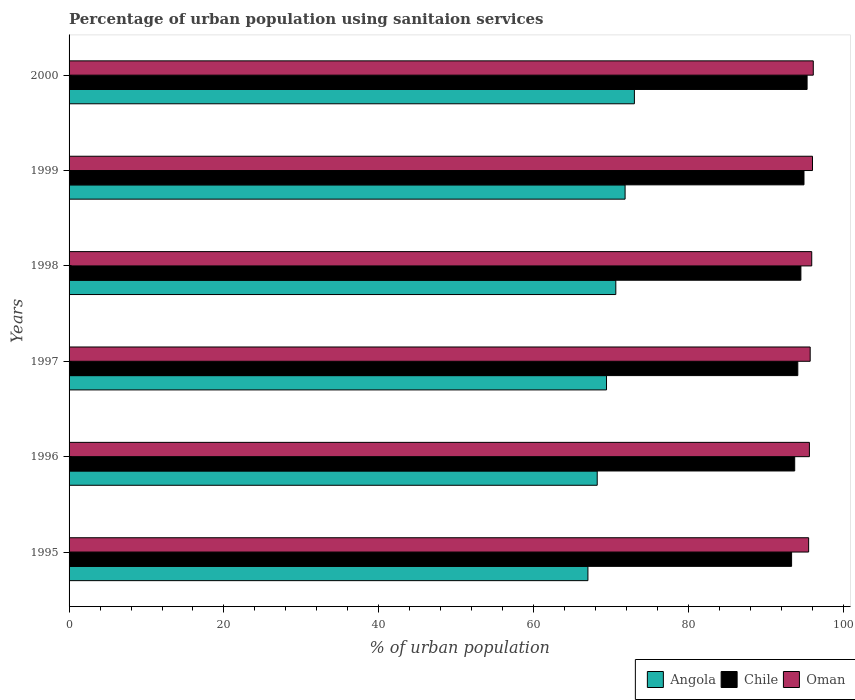How many groups of bars are there?
Offer a very short reply. 6. How many bars are there on the 4th tick from the top?
Offer a terse response. 3. How many bars are there on the 6th tick from the bottom?
Offer a very short reply. 3. In how many cases, is the number of bars for a given year not equal to the number of legend labels?
Ensure brevity in your answer.  0. What is the percentage of urban population using sanitaion services in Angola in 2000?
Ensure brevity in your answer.  73. Across all years, what is the maximum percentage of urban population using sanitaion services in Chile?
Give a very brief answer. 95.3. Across all years, what is the minimum percentage of urban population using sanitaion services in Angola?
Offer a terse response. 67. In which year was the percentage of urban population using sanitaion services in Chile maximum?
Your answer should be compact. 2000. In which year was the percentage of urban population using sanitaion services in Angola minimum?
Offer a very short reply. 1995. What is the total percentage of urban population using sanitaion services in Oman in the graph?
Give a very brief answer. 574.8. What is the difference between the percentage of urban population using sanitaion services in Oman in 1996 and that in 1997?
Your answer should be compact. -0.1. What is the difference between the percentage of urban population using sanitaion services in Angola in 2000 and the percentage of urban population using sanitaion services in Chile in 1997?
Your answer should be compact. -21.1. What is the average percentage of urban population using sanitaion services in Chile per year?
Provide a succinct answer. 94.3. In the year 1996, what is the difference between the percentage of urban population using sanitaion services in Chile and percentage of urban population using sanitaion services in Angola?
Offer a very short reply. 25.5. What is the ratio of the percentage of urban population using sanitaion services in Oman in 1998 to that in 1999?
Your answer should be very brief. 1. Is the difference between the percentage of urban population using sanitaion services in Chile in 1996 and 1997 greater than the difference between the percentage of urban population using sanitaion services in Angola in 1996 and 1997?
Ensure brevity in your answer.  Yes. What is the difference between the highest and the second highest percentage of urban population using sanitaion services in Oman?
Your response must be concise. 0.1. What is the difference between the highest and the lowest percentage of urban population using sanitaion services in Oman?
Offer a very short reply. 0.6. In how many years, is the percentage of urban population using sanitaion services in Angola greater than the average percentage of urban population using sanitaion services in Angola taken over all years?
Offer a terse response. 3. Is the sum of the percentage of urban population using sanitaion services in Oman in 1997 and 1998 greater than the maximum percentage of urban population using sanitaion services in Chile across all years?
Ensure brevity in your answer.  Yes. What does the 1st bar from the top in 1996 represents?
Offer a terse response. Oman. What does the 1st bar from the bottom in 1998 represents?
Provide a short and direct response. Angola. Is it the case that in every year, the sum of the percentage of urban population using sanitaion services in Oman and percentage of urban population using sanitaion services in Angola is greater than the percentage of urban population using sanitaion services in Chile?
Give a very brief answer. Yes. Are all the bars in the graph horizontal?
Keep it short and to the point. Yes. How many years are there in the graph?
Provide a succinct answer. 6. Does the graph contain grids?
Provide a short and direct response. No. Where does the legend appear in the graph?
Your answer should be compact. Bottom right. How are the legend labels stacked?
Your response must be concise. Horizontal. What is the title of the graph?
Ensure brevity in your answer.  Percentage of urban population using sanitaion services. Does "North America" appear as one of the legend labels in the graph?
Offer a terse response. No. What is the label or title of the X-axis?
Provide a succinct answer. % of urban population. What is the label or title of the Y-axis?
Give a very brief answer. Years. What is the % of urban population of Angola in 1995?
Your answer should be compact. 67. What is the % of urban population of Chile in 1995?
Offer a very short reply. 93.3. What is the % of urban population in Oman in 1995?
Ensure brevity in your answer.  95.5. What is the % of urban population in Angola in 1996?
Your response must be concise. 68.2. What is the % of urban population in Chile in 1996?
Give a very brief answer. 93.7. What is the % of urban population of Oman in 1996?
Provide a succinct answer. 95.6. What is the % of urban population of Angola in 1997?
Your answer should be compact. 69.4. What is the % of urban population of Chile in 1997?
Offer a very short reply. 94.1. What is the % of urban population of Oman in 1997?
Provide a short and direct response. 95.7. What is the % of urban population of Angola in 1998?
Ensure brevity in your answer.  70.6. What is the % of urban population in Chile in 1998?
Make the answer very short. 94.5. What is the % of urban population in Oman in 1998?
Give a very brief answer. 95.9. What is the % of urban population of Angola in 1999?
Offer a terse response. 71.8. What is the % of urban population of Chile in 1999?
Your response must be concise. 94.9. What is the % of urban population in Oman in 1999?
Your answer should be compact. 96. What is the % of urban population of Chile in 2000?
Your answer should be very brief. 95.3. What is the % of urban population of Oman in 2000?
Your response must be concise. 96.1. Across all years, what is the maximum % of urban population of Chile?
Provide a succinct answer. 95.3. Across all years, what is the maximum % of urban population of Oman?
Offer a very short reply. 96.1. Across all years, what is the minimum % of urban population of Chile?
Give a very brief answer. 93.3. Across all years, what is the minimum % of urban population in Oman?
Offer a very short reply. 95.5. What is the total % of urban population in Angola in the graph?
Offer a terse response. 420. What is the total % of urban population of Chile in the graph?
Your answer should be compact. 565.8. What is the total % of urban population of Oman in the graph?
Make the answer very short. 574.8. What is the difference between the % of urban population of Oman in 1995 and that in 1997?
Provide a short and direct response. -0.2. What is the difference between the % of urban population of Angola in 1995 and that in 1998?
Your answer should be very brief. -3.6. What is the difference between the % of urban population of Chile in 1995 and that in 1998?
Ensure brevity in your answer.  -1.2. What is the difference between the % of urban population in Oman in 1995 and that in 1998?
Keep it short and to the point. -0.4. What is the difference between the % of urban population in Angola in 1995 and that in 1999?
Make the answer very short. -4.8. What is the difference between the % of urban population of Chile in 1995 and that in 1999?
Give a very brief answer. -1.6. What is the difference between the % of urban population of Oman in 1995 and that in 1999?
Offer a terse response. -0.5. What is the difference between the % of urban population of Angola in 1995 and that in 2000?
Your answer should be compact. -6. What is the difference between the % of urban population in Oman in 1996 and that in 1998?
Keep it short and to the point. -0.3. What is the difference between the % of urban population of Angola in 1996 and that in 2000?
Your answer should be compact. -4.8. What is the difference between the % of urban population of Angola in 1997 and that in 1998?
Your answer should be very brief. -1.2. What is the difference between the % of urban population in Angola in 1997 and that in 1999?
Offer a very short reply. -2.4. What is the difference between the % of urban population of Angola in 1997 and that in 2000?
Provide a short and direct response. -3.6. What is the difference between the % of urban population of Chile in 1997 and that in 2000?
Your answer should be compact. -1.2. What is the difference between the % of urban population of Oman in 1997 and that in 2000?
Provide a short and direct response. -0.4. What is the difference between the % of urban population of Oman in 1998 and that in 1999?
Provide a short and direct response. -0.1. What is the difference between the % of urban population of Angola in 1998 and that in 2000?
Provide a short and direct response. -2.4. What is the difference between the % of urban population of Chile in 1998 and that in 2000?
Offer a very short reply. -0.8. What is the difference between the % of urban population in Oman in 1998 and that in 2000?
Provide a succinct answer. -0.2. What is the difference between the % of urban population in Angola in 1999 and that in 2000?
Provide a short and direct response. -1.2. What is the difference between the % of urban population of Chile in 1999 and that in 2000?
Offer a very short reply. -0.4. What is the difference between the % of urban population of Angola in 1995 and the % of urban population of Chile in 1996?
Make the answer very short. -26.7. What is the difference between the % of urban population of Angola in 1995 and the % of urban population of Oman in 1996?
Make the answer very short. -28.6. What is the difference between the % of urban population of Chile in 1995 and the % of urban population of Oman in 1996?
Provide a succinct answer. -2.3. What is the difference between the % of urban population in Angola in 1995 and the % of urban population in Chile in 1997?
Offer a terse response. -27.1. What is the difference between the % of urban population in Angola in 1995 and the % of urban population in Oman in 1997?
Your response must be concise. -28.7. What is the difference between the % of urban population of Chile in 1995 and the % of urban population of Oman in 1997?
Your answer should be compact. -2.4. What is the difference between the % of urban population of Angola in 1995 and the % of urban population of Chile in 1998?
Provide a short and direct response. -27.5. What is the difference between the % of urban population in Angola in 1995 and the % of urban population in Oman in 1998?
Provide a short and direct response. -28.9. What is the difference between the % of urban population of Angola in 1995 and the % of urban population of Chile in 1999?
Provide a succinct answer. -27.9. What is the difference between the % of urban population of Chile in 1995 and the % of urban population of Oman in 1999?
Keep it short and to the point. -2.7. What is the difference between the % of urban population in Angola in 1995 and the % of urban population in Chile in 2000?
Ensure brevity in your answer.  -28.3. What is the difference between the % of urban population of Angola in 1995 and the % of urban population of Oman in 2000?
Ensure brevity in your answer.  -29.1. What is the difference between the % of urban population of Chile in 1995 and the % of urban population of Oman in 2000?
Provide a short and direct response. -2.8. What is the difference between the % of urban population in Angola in 1996 and the % of urban population in Chile in 1997?
Ensure brevity in your answer.  -25.9. What is the difference between the % of urban population in Angola in 1996 and the % of urban population in Oman in 1997?
Give a very brief answer. -27.5. What is the difference between the % of urban population in Chile in 1996 and the % of urban population in Oman in 1997?
Your answer should be compact. -2. What is the difference between the % of urban population in Angola in 1996 and the % of urban population in Chile in 1998?
Provide a short and direct response. -26.3. What is the difference between the % of urban population of Angola in 1996 and the % of urban population of Oman in 1998?
Give a very brief answer. -27.7. What is the difference between the % of urban population in Chile in 1996 and the % of urban population in Oman in 1998?
Keep it short and to the point. -2.2. What is the difference between the % of urban population of Angola in 1996 and the % of urban population of Chile in 1999?
Give a very brief answer. -26.7. What is the difference between the % of urban population of Angola in 1996 and the % of urban population of Oman in 1999?
Your response must be concise. -27.8. What is the difference between the % of urban population in Chile in 1996 and the % of urban population in Oman in 1999?
Keep it short and to the point. -2.3. What is the difference between the % of urban population of Angola in 1996 and the % of urban population of Chile in 2000?
Make the answer very short. -27.1. What is the difference between the % of urban population in Angola in 1996 and the % of urban population in Oman in 2000?
Your response must be concise. -27.9. What is the difference between the % of urban population of Chile in 1996 and the % of urban population of Oman in 2000?
Offer a very short reply. -2.4. What is the difference between the % of urban population in Angola in 1997 and the % of urban population in Chile in 1998?
Provide a succinct answer. -25.1. What is the difference between the % of urban population in Angola in 1997 and the % of urban population in Oman in 1998?
Make the answer very short. -26.5. What is the difference between the % of urban population in Chile in 1997 and the % of urban population in Oman in 1998?
Ensure brevity in your answer.  -1.8. What is the difference between the % of urban population in Angola in 1997 and the % of urban population in Chile in 1999?
Offer a terse response. -25.5. What is the difference between the % of urban population in Angola in 1997 and the % of urban population in Oman in 1999?
Make the answer very short. -26.6. What is the difference between the % of urban population of Angola in 1997 and the % of urban population of Chile in 2000?
Provide a short and direct response. -25.9. What is the difference between the % of urban population in Angola in 1997 and the % of urban population in Oman in 2000?
Keep it short and to the point. -26.7. What is the difference between the % of urban population in Angola in 1998 and the % of urban population in Chile in 1999?
Your answer should be very brief. -24.3. What is the difference between the % of urban population in Angola in 1998 and the % of urban population in Oman in 1999?
Offer a very short reply. -25.4. What is the difference between the % of urban population in Angola in 1998 and the % of urban population in Chile in 2000?
Your response must be concise. -24.7. What is the difference between the % of urban population in Angola in 1998 and the % of urban population in Oman in 2000?
Ensure brevity in your answer.  -25.5. What is the difference between the % of urban population of Angola in 1999 and the % of urban population of Chile in 2000?
Offer a terse response. -23.5. What is the difference between the % of urban population in Angola in 1999 and the % of urban population in Oman in 2000?
Make the answer very short. -24.3. What is the difference between the % of urban population of Chile in 1999 and the % of urban population of Oman in 2000?
Provide a succinct answer. -1.2. What is the average % of urban population in Chile per year?
Make the answer very short. 94.3. What is the average % of urban population in Oman per year?
Your answer should be compact. 95.8. In the year 1995, what is the difference between the % of urban population of Angola and % of urban population of Chile?
Provide a short and direct response. -26.3. In the year 1995, what is the difference between the % of urban population of Angola and % of urban population of Oman?
Offer a very short reply. -28.5. In the year 1996, what is the difference between the % of urban population of Angola and % of urban population of Chile?
Make the answer very short. -25.5. In the year 1996, what is the difference between the % of urban population of Angola and % of urban population of Oman?
Provide a succinct answer. -27.4. In the year 1996, what is the difference between the % of urban population in Chile and % of urban population in Oman?
Keep it short and to the point. -1.9. In the year 1997, what is the difference between the % of urban population of Angola and % of urban population of Chile?
Offer a terse response. -24.7. In the year 1997, what is the difference between the % of urban population in Angola and % of urban population in Oman?
Give a very brief answer. -26.3. In the year 1998, what is the difference between the % of urban population of Angola and % of urban population of Chile?
Your response must be concise. -23.9. In the year 1998, what is the difference between the % of urban population of Angola and % of urban population of Oman?
Your response must be concise. -25.3. In the year 1998, what is the difference between the % of urban population in Chile and % of urban population in Oman?
Offer a terse response. -1.4. In the year 1999, what is the difference between the % of urban population in Angola and % of urban population in Chile?
Your answer should be very brief. -23.1. In the year 1999, what is the difference between the % of urban population of Angola and % of urban population of Oman?
Offer a very short reply. -24.2. In the year 2000, what is the difference between the % of urban population of Angola and % of urban population of Chile?
Keep it short and to the point. -22.3. In the year 2000, what is the difference between the % of urban population in Angola and % of urban population in Oman?
Offer a very short reply. -23.1. What is the ratio of the % of urban population of Angola in 1995 to that in 1996?
Provide a short and direct response. 0.98. What is the ratio of the % of urban population of Chile in 1995 to that in 1996?
Your answer should be very brief. 1. What is the ratio of the % of urban population in Oman in 1995 to that in 1996?
Ensure brevity in your answer.  1. What is the ratio of the % of urban population of Angola in 1995 to that in 1997?
Offer a very short reply. 0.97. What is the ratio of the % of urban population of Angola in 1995 to that in 1998?
Offer a terse response. 0.95. What is the ratio of the % of urban population of Chile in 1995 to that in 1998?
Ensure brevity in your answer.  0.99. What is the ratio of the % of urban population in Oman in 1995 to that in 1998?
Your response must be concise. 1. What is the ratio of the % of urban population of Angola in 1995 to that in 1999?
Make the answer very short. 0.93. What is the ratio of the % of urban population of Chile in 1995 to that in 1999?
Provide a short and direct response. 0.98. What is the ratio of the % of urban population in Oman in 1995 to that in 1999?
Provide a short and direct response. 0.99. What is the ratio of the % of urban population of Angola in 1995 to that in 2000?
Your answer should be very brief. 0.92. What is the ratio of the % of urban population of Angola in 1996 to that in 1997?
Make the answer very short. 0.98. What is the ratio of the % of urban population of Chile in 1996 to that in 1997?
Offer a very short reply. 1. What is the ratio of the % of urban population of Oman in 1996 to that in 1997?
Give a very brief answer. 1. What is the ratio of the % of urban population of Angola in 1996 to that in 1998?
Offer a very short reply. 0.97. What is the ratio of the % of urban population in Chile in 1996 to that in 1998?
Provide a succinct answer. 0.99. What is the ratio of the % of urban population of Oman in 1996 to that in 1998?
Your response must be concise. 1. What is the ratio of the % of urban population in Angola in 1996 to that in 1999?
Offer a terse response. 0.95. What is the ratio of the % of urban population of Chile in 1996 to that in 1999?
Keep it short and to the point. 0.99. What is the ratio of the % of urban population of Angola in 1996 to that in 2000?
Offer a very short reply. 0.93. What is the ratio of the % of urban population of Chile in 1996 to that in 2000?
Your response must be concise. 0.98. What is the ratio of the % of urban population of Oman in 1996 to that in 2000?
Your answer should be compact. 0.99. What is the ratio of the % of urban population in Chile in 1997 to that in 1998?
Your answer should be compact. 1. What is the ratio of the % of urban population of Oman in 1997 to that in 1998?
Provide a short and direct response. 1. What is the ratio of the % of urban population in Angola in 1997 to that in 1999?
Offer a terse response. 0.97. What is the ratio of the % of urban population of Chile in 1997 to that in 1999?
Provide a short and direct response. 0.99. What is the ratio of the % of urban population in Oman in 1997 to that in 1999?
Keep it short and to the point. 1. What is the ratio of the % of urban population of Angola in 1997 to that in 2000?
Offer a terse response. 0.95. What is the ratio of the % of urban population in Chile in 1997 to that in 2000?
Your answer should be compact. 0.99. What is the ratio of the % of urban population in Oman in 1997 to that in 2000?
Give a very brief answer. 1. What is the ratio of the % of urban population of Angola in 1998 to that in 1999?
Keep it short and to the point. 0.98. What is the ratio of the % of urban population in Chile in 1998 to that in 1999?
Offer a terse response. 1. What is the ratio of the % of urban population of Oman in 1998 to that in 1999?
Offer a terse response. 1. What is the ratio of the % of urban population in Angola in 1998 to that in 2000?
Give a very brief answer. 0.97. What is the ratio of the % of urban population in Chile in 1998 to that in 2000?
Offer a terse response. 0.99. What is the ratio of the % of urban population of Oman in 1998 to that in 2000?
Provide a succinct answer. 1. What is the ratio of the % of urban population in Angola in 1999 to that in 2000?
Ensure brevity in your answer.  0.98. What is the difference between the highest and the second highest % of urban population of Angola?
Give a very brief answer. 1.2. What is the difference between the highest and the lowest % of urban population of Angola?
Offer a terse response. 6. What is the difference between the highest and the lowest % of urban population of Chile?
Your response must be concise. 2. What is the difference between the highest and the lowest % of urban population in Oman?
Ensure brevity in your answer.  0.6. 